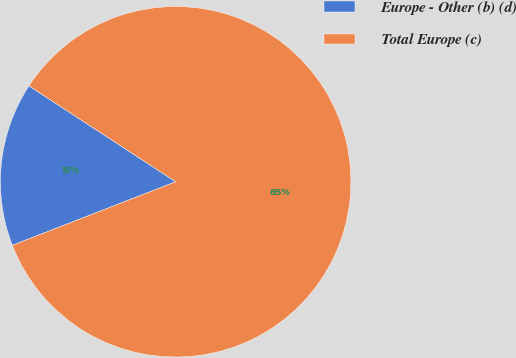Convert chart to OTSL. <chart><loc_0><loc_0><loc_500><loc_500><pie_chart><fcel>Europe - Other (b) (d)<fcel>Total Europe (c)<nl><fcel>15.12%<fcel>84.88%<nl></chart> 